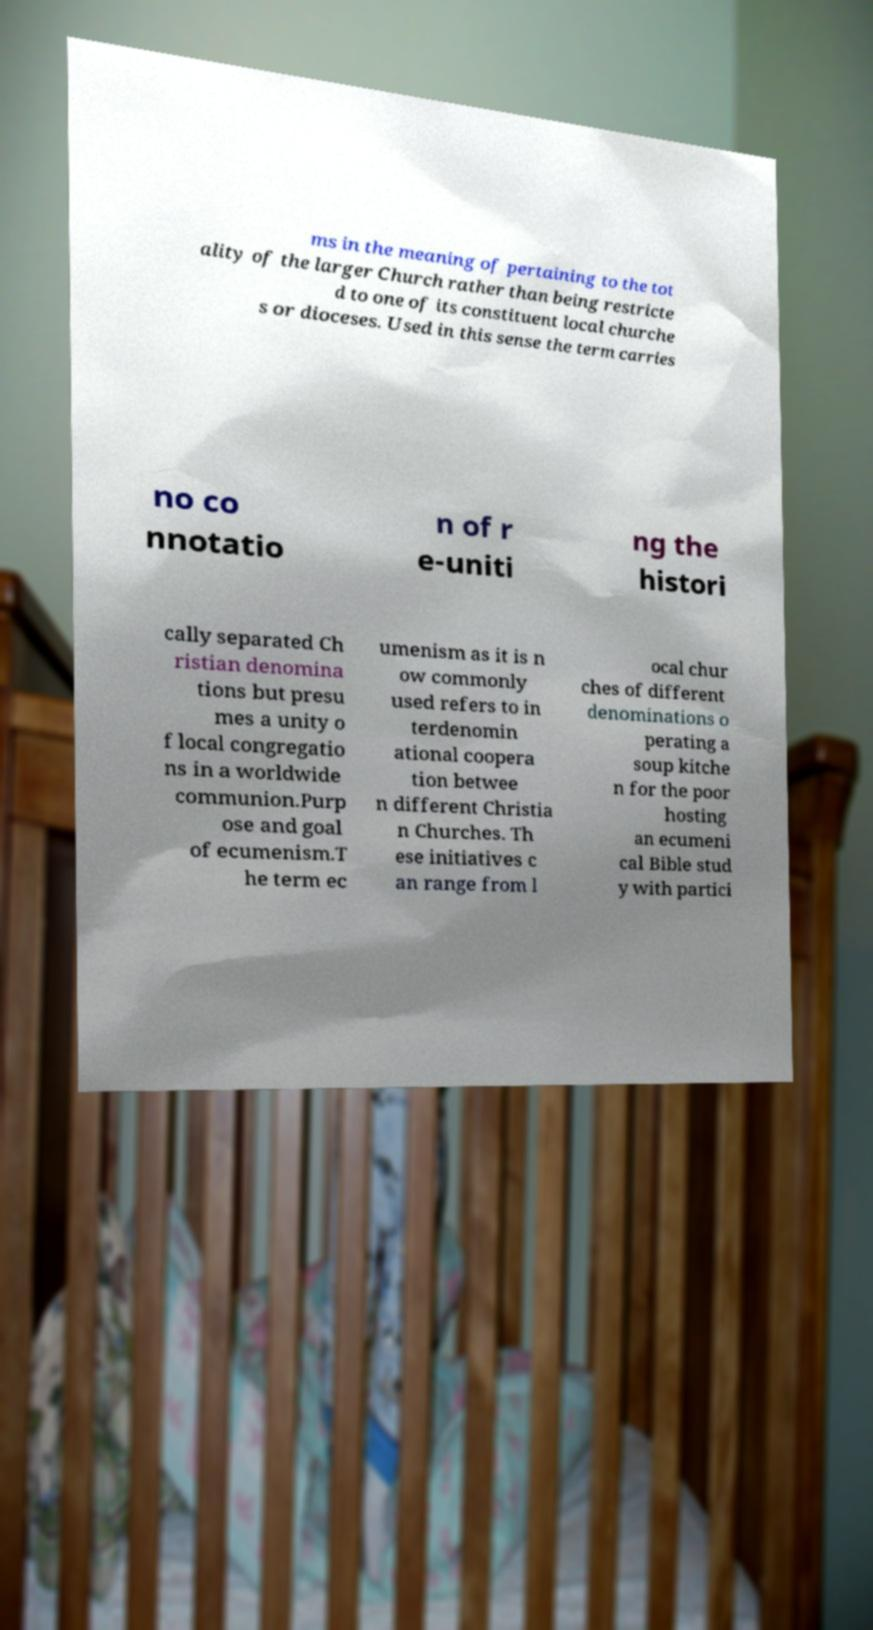Can you accurately transcribe the text from the provided image for me? ms in the meaning of pertaining to the tot ality of the larger Church rather than being restricte d to one of its constituent local churche s or dioceses. Used in this sense the term carries no co nnotatio n of r e-uniti ng the histori cally separated Ch ristian denomina tions but presu mes a unity o f local congregatio ns in a worldwide communion.Purp ose and goal of ecumenism.T he term ec umenism as it is n ow commonly used refers to in terdenomin ational coopera tion betwee n different Christia n Churches. Th ese initiatives c an range from l ocal chur ches of different denominations o perating a soup kitche n for the poor hosting an ecumeni cal Bible stud y with partici 